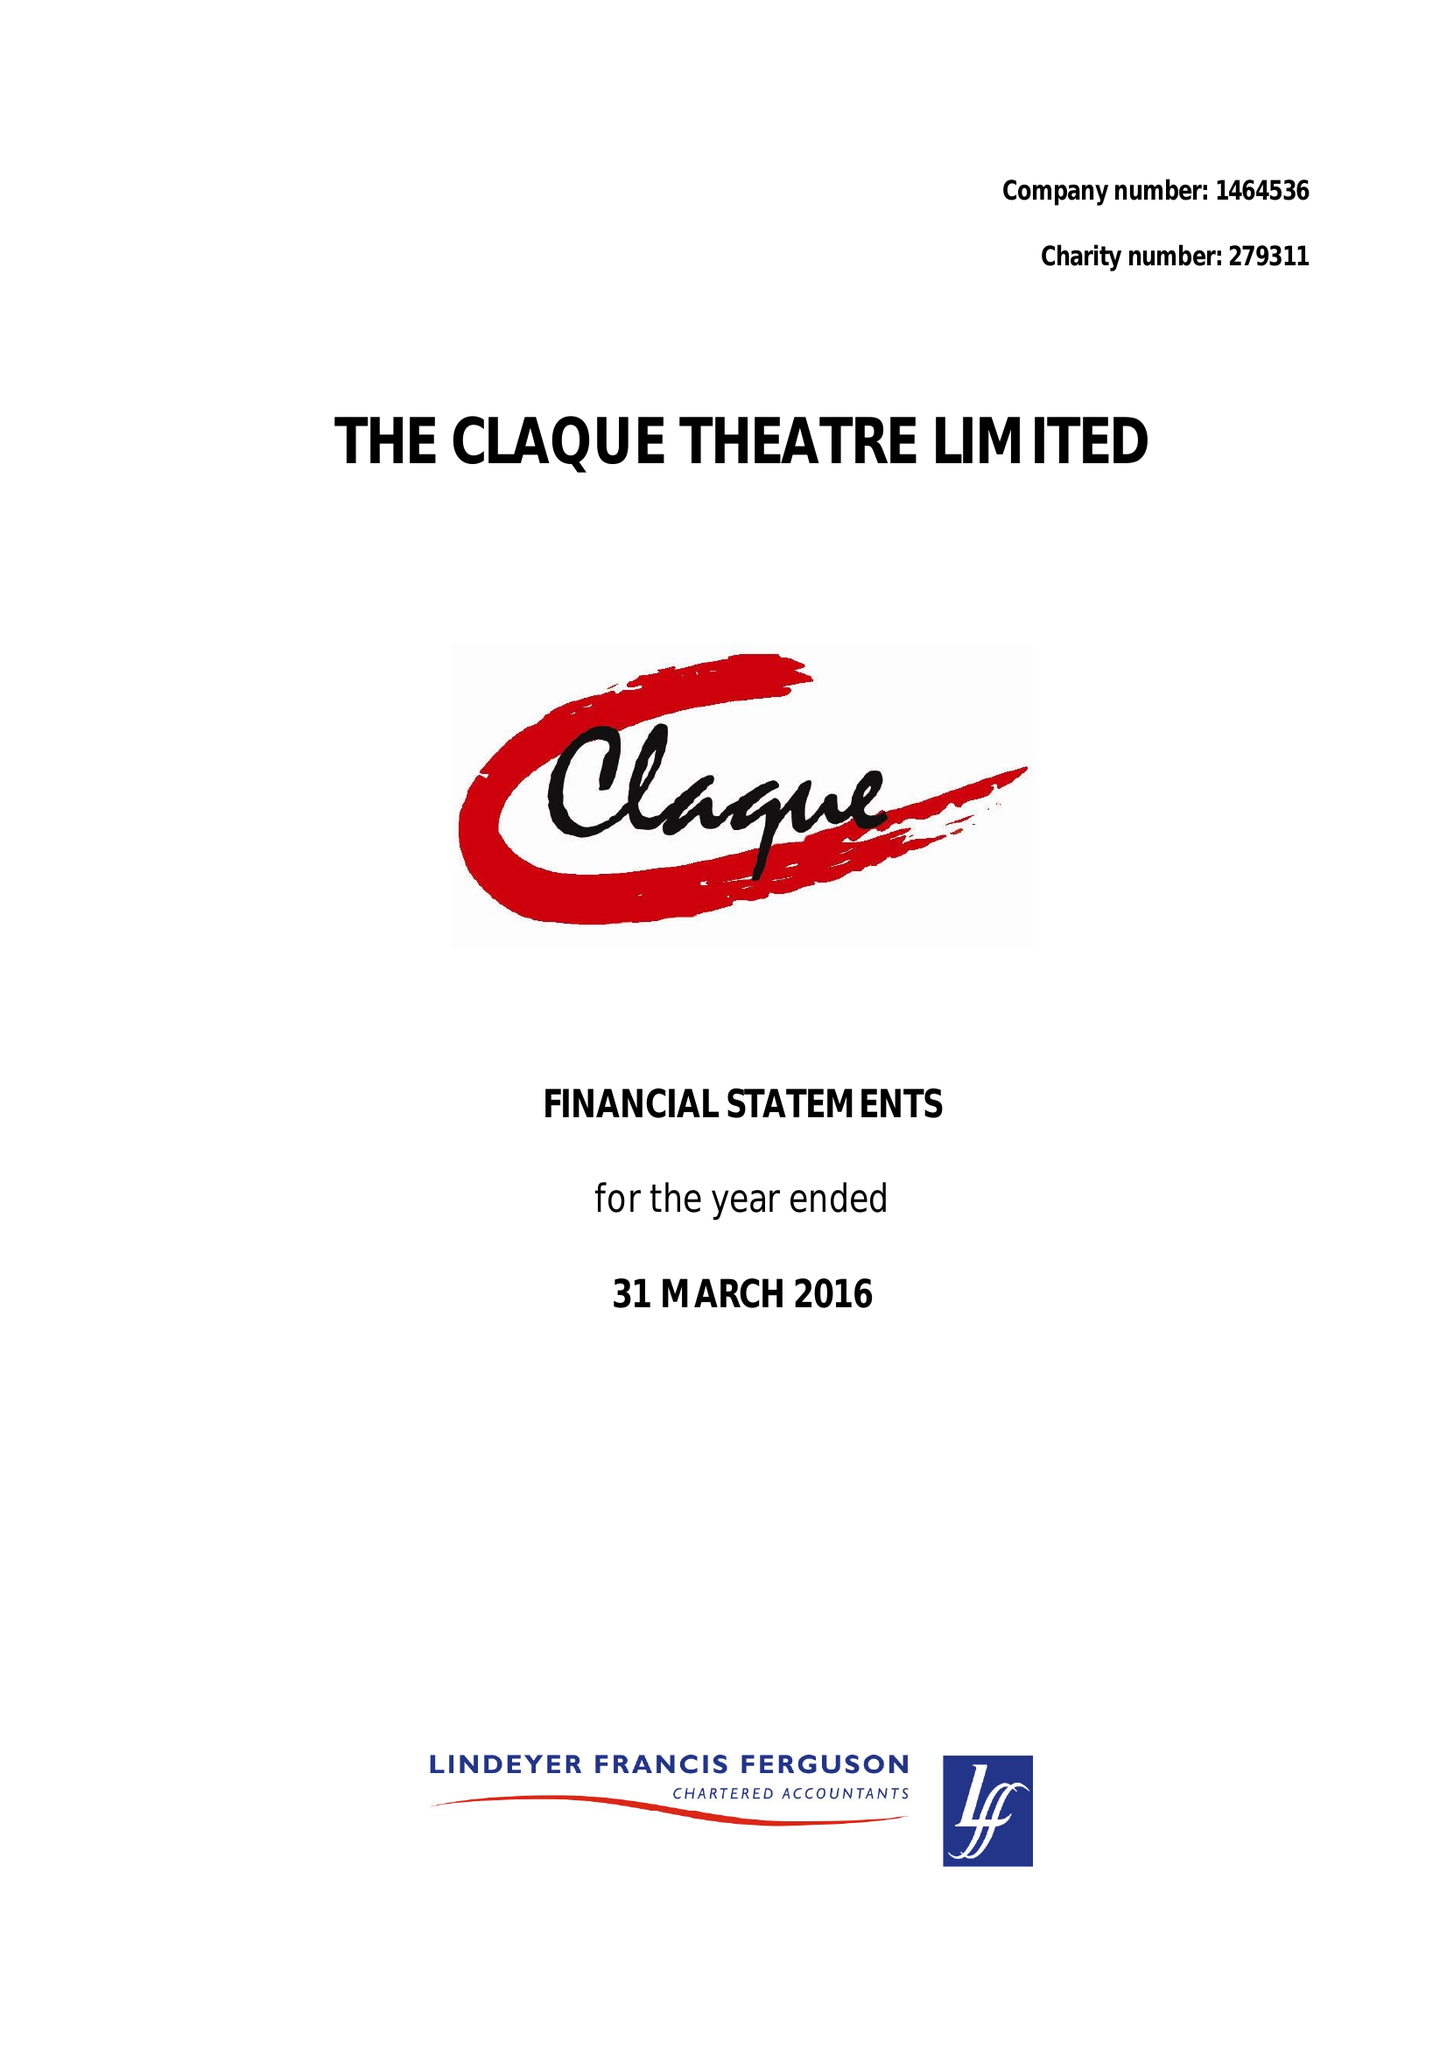What is the value for the income_annually_in_british_pounds?
Answer the question using a single word or phrase. 48850.00 